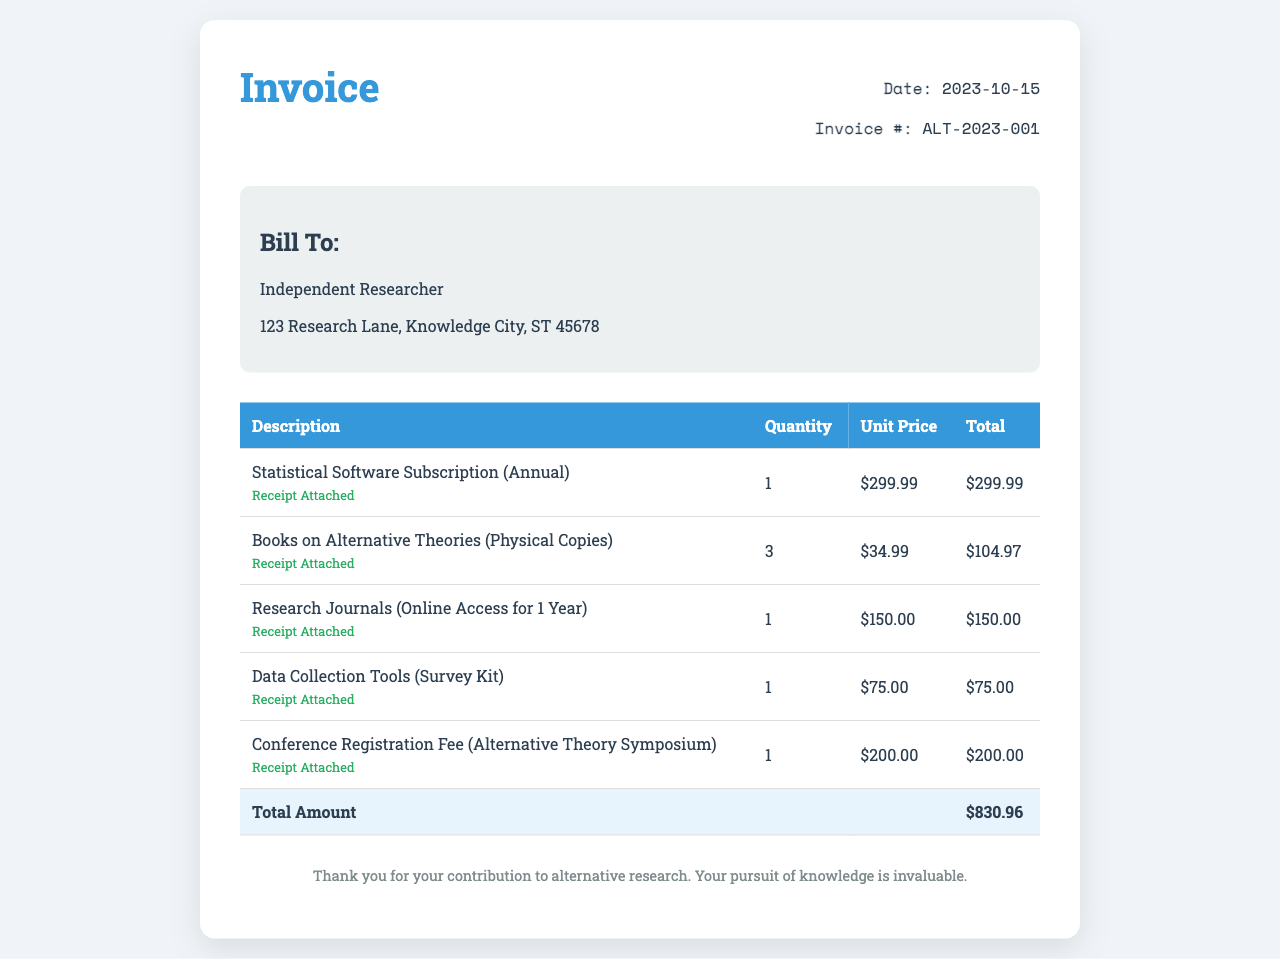what is the invoice date? The invoice date can be found in the invoice details section, which is October 15, 2023.
Answer: October 15, 2023 what is the total amount of the invoice? The total amount is listed in the total row of the table, which sums up all item costs.
Answer: $830.96 how many books on alternative theories were purchased? The quantity of books on alternative theories is indicated in the itemized listing in the table.
Answer: 3 who is the invoice billed to? The billing information section provides the name of the person or entity the invoice is addressed to.
Answer: Independent Researcher what is the unit price of the statistical software subscription? The unit price for the statistical software subscription is included in the pricing details of the table.
Answer: $299.99 what is the purpose of the conference registration fee listed? The purpose of the conference registration fee is implied in its description, which mentions an Alternative Theory Symposium.
Answer: Alternative Theory Symposium how many items have receipts attached? Each item in the invoice has a receipt status indicated, suggesting that all items include receipts.
Answer: 5 what type of document is this? The nature of the document is specified in the title section, which indicates it is an invoice.
Answer: Invoice who is the author of the invoice? The author's information can typically be found in the header, but in this case, it is not explicitly stated who issued the invoice.
Answer: Not explicitly stated 